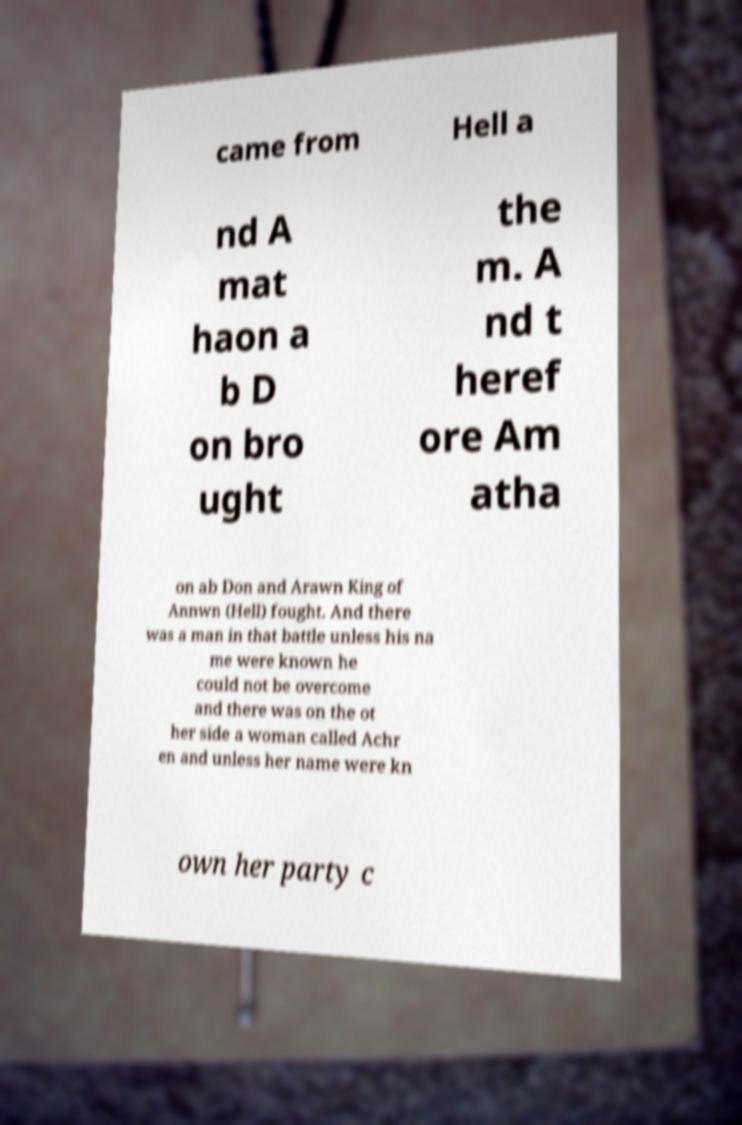Could you extract and type out the text from this image? came from Hell a nd A mat haon a b D on bro ught the m. A nd t heref ore Am atha on ab Don and Arawn King of Annwn (Hell) fought. And there was a man in that battle unless his na me were known he could not be overcome and there was on the ot her side a woman called Achr en and unless her name were kn own her party c 